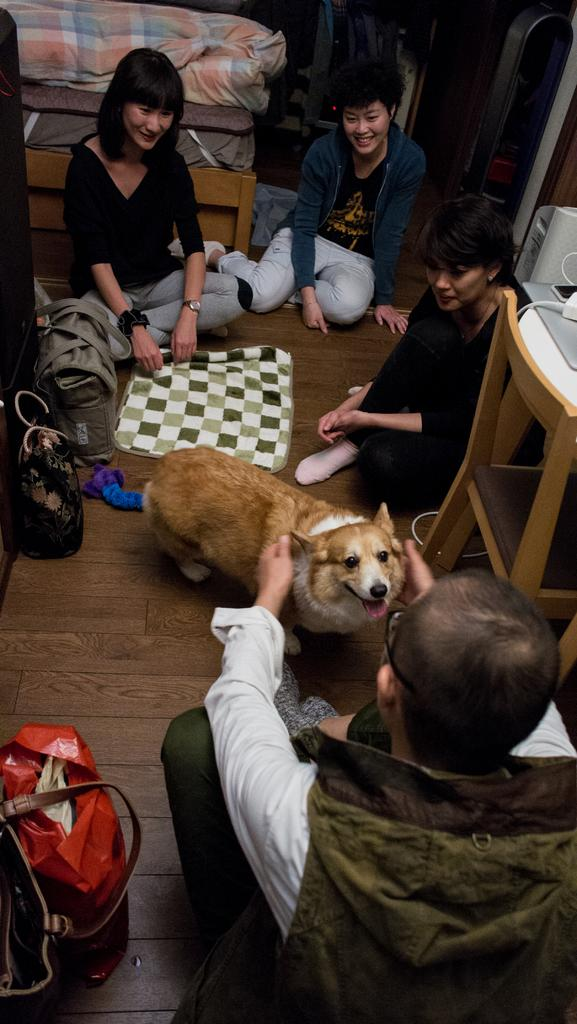Who is present in the image? There are people in the image. What are the people doing in the image? The people are sitting on the floor and playing with a dog. What type of flesh can be seen on the people's faces in the image? There is no mention of the people's faces or any flesh in the image; it only states that the people are sitting on the floor and playing with a dog. 